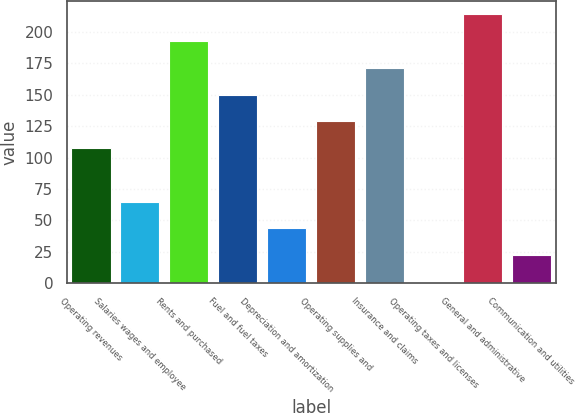<chart> <loc_0><loc_0><loc_500><loc_500><bar_chart><fcel>Operating revenues<fcel>Salaries wages and employee<fcel>Rents and purchased<fcel>Fuel and fuel taxes<fcel>Depreciation and amortization<fcel>Operating supplies and<fcel>Insurance and claims<fcel>Operating taxes and licenses<fcel>General and administrative<fcel>Communication and utilities<nl><fcel>107.55<fcel>65.05<fcel>192.55<fcel>150.05<fcel>43.8<fcel>128.8<fcel>171.3<fcel>1.3<fcel>213.8<fcel>22.55<nl></chart> 